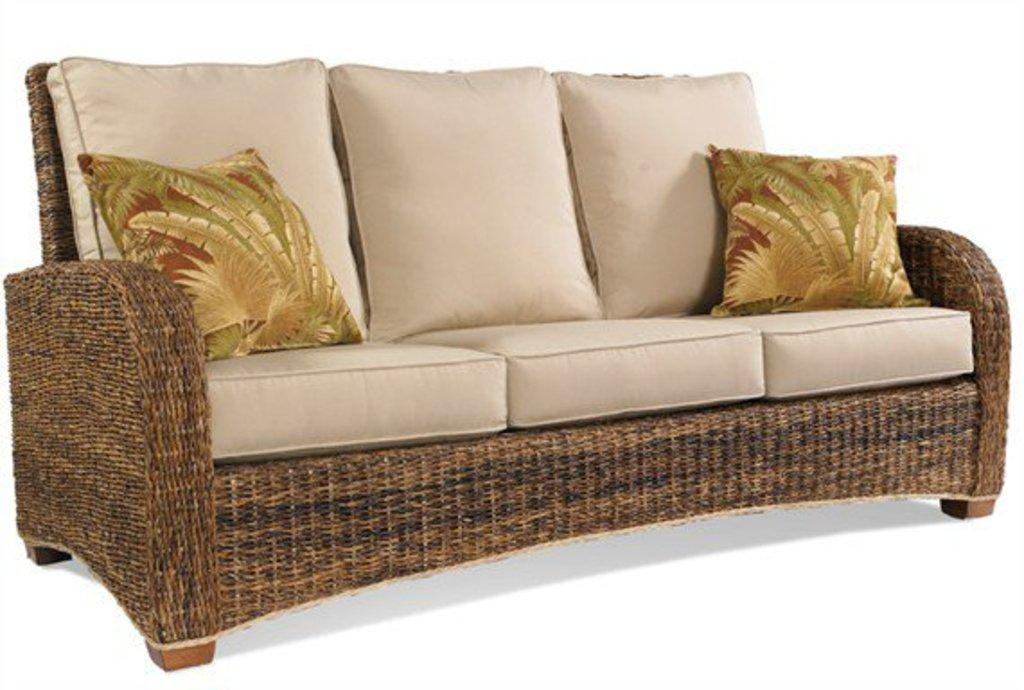What type of furniture is present in the image? There is a sofa in the image. How many cushions are on the sofa? The sofa has two cushions on it. What type of art is hanging above the sofa in the image? There is no art visible above the sofa in the image. 